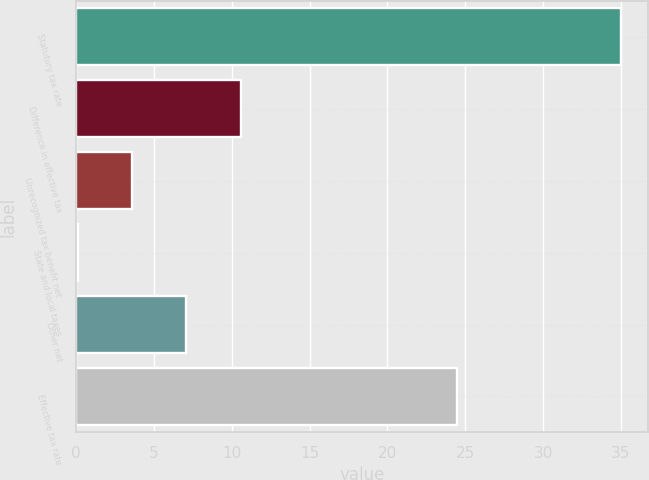<chart> <loc_0><loc_0><loc_500><loc_500><bar_chart><fcel>Statutory tax rate<fcel>Difference in effective tax<fcel>Unrecognized tax benefit net<fcel>State and local taxes<fcel>Other net<fcel>Effective tax rate<nl><fcel>35<fcel>10.57<fcel>3.59<fcel>0.1<fcel>7.08<fcel>24.5<nl></chart> 